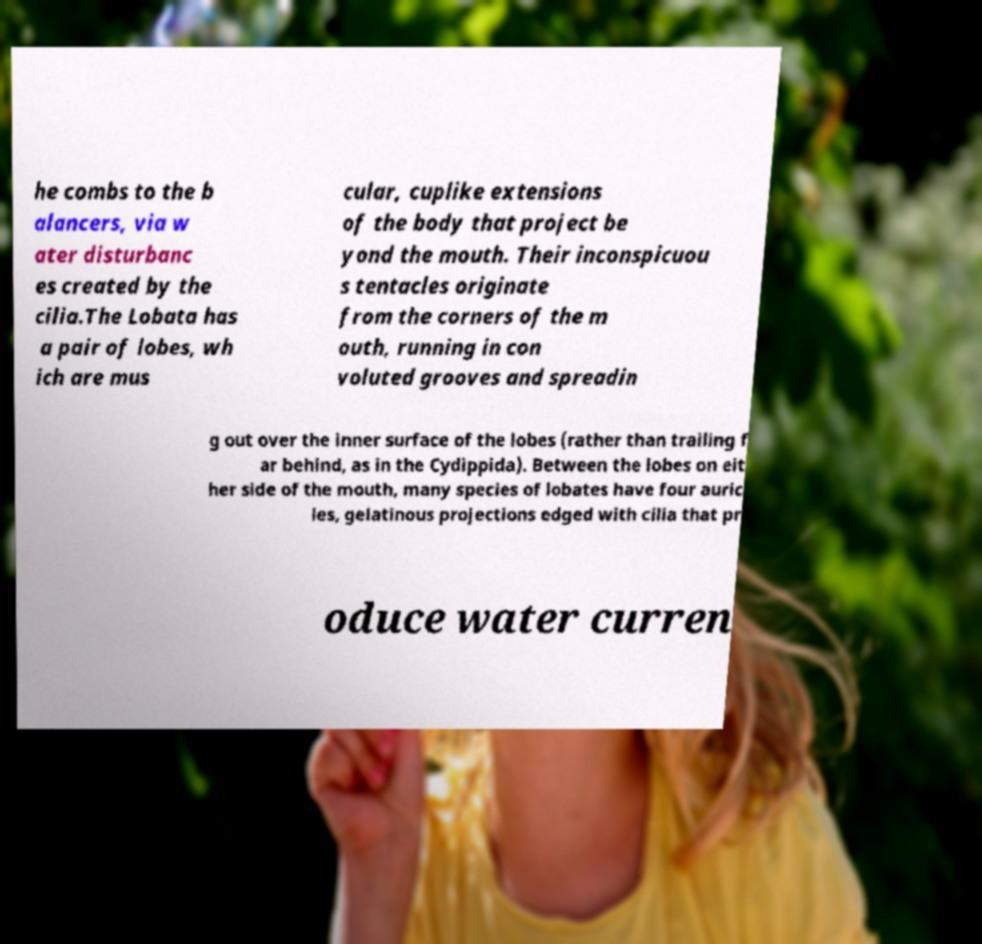Please identify and transcribe the text found in this image. he combs to the b alancers, via w ater disturbanc es created by the cilia.The Lobata has a pair of lobes, wh ich are mus cular, cuplike extensions of the body that project be yond the mouth. Their inconspicuou s tentacles originate from the corners of the m outh, running in con voluted grooves and spreadin g out over the inner surface of the lobes (rather than trailing f ar behind, as in the Cydippida). Between the lobes on eit her side of the mouth, many species of lobates have four auric les, gelatinous projections edged with cilia that pr oduce water curren 